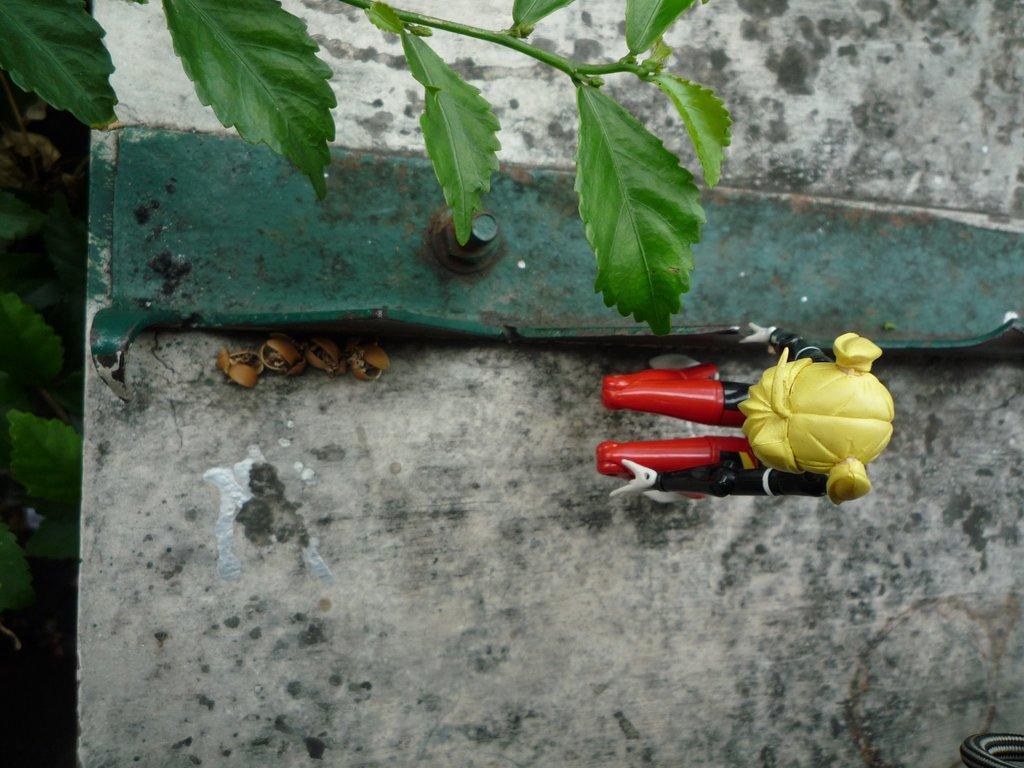How would you summarize this image in a sentence or two? In this image I can see the toy in red, yellow and black color. I can see few green color leaves. The toy is on the grey and white color surface and I can see the green color iron object is attached to the surface. 